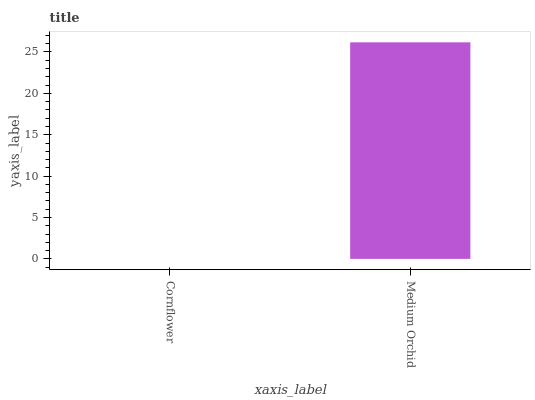Is Cornflower the minimum?
Answer yes or no. Yes. Is Medium Orchid the maximum?
Answer yes or no. Yes. Is Medium Orchid the minimum?
Answer yes or no. No. Is Medium Orchid greater than Cornflower?
Answer yes or no. Yes. Is Cornflower less than Medium Orchid?
Answer yes or no. Yes. Is Cornflower greater than Medium Orchid?
Answer yes or no. No. Is Medium Orchid less than Cornflower?
Answer yes or no. No. Is Medium Orchid the high median?
Answer yes or no. Yes. Is Cornflower the low median?
Answer yes or no. Yes. Is Cornflower the high median?
Answer yes or no. No. Is Medium Orchid the low median?
Answer yes or no. No. 